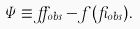<formula> <loc_0><loc_0><loc_500><loc_500>\Psi \equiv \alpha _ { o b s } - f ( \beta _ { o b s } ) .</formula> 